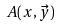Convert formula to latex. <formula><loc_0><loc_0><loc_500><loc_500>A ( x , \vec { y } )</formula> 